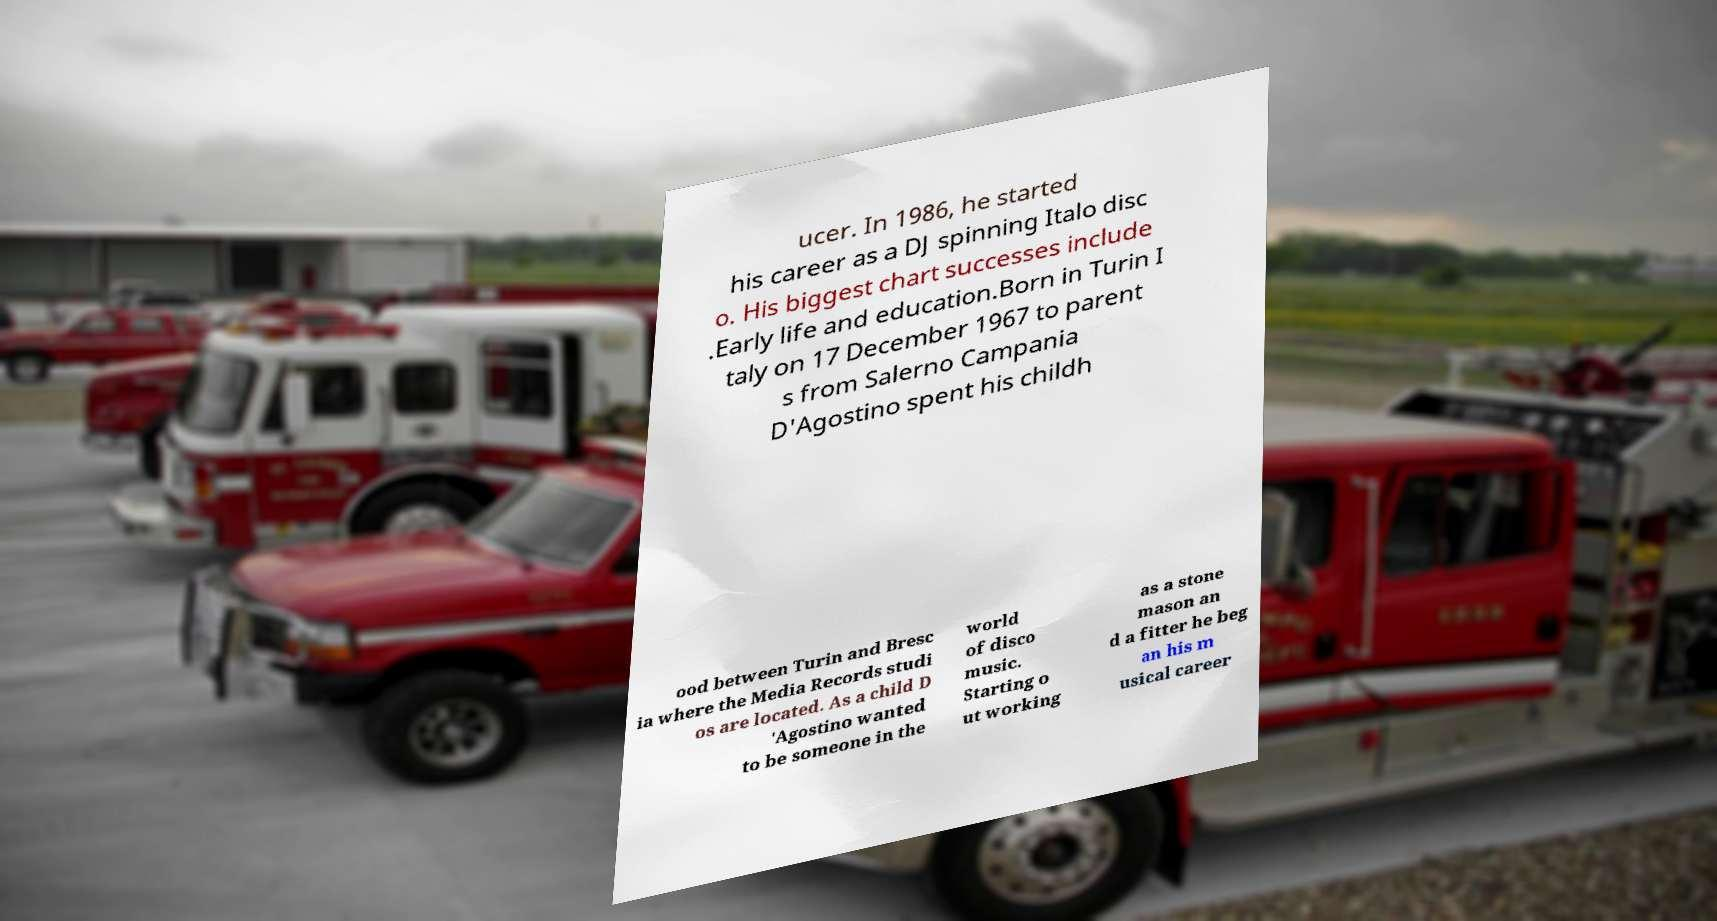Please identify and transcribe the text found in this image. ucer. In 1986, he started his career as a DJ spinning Italo disc o. His biggest chart successes include .Early life and education.Born in Turin I taly on 17 December 1967 to parent s from Salerno Campania D'Agostino spent his childh ood between Turin and Bresc ia where the Media Records studi os are located. As a child D 'Agostino wanted to be someone in the world of disco music. Starting o ut working as a stone mason an d a fitter he beg an his m usical career 